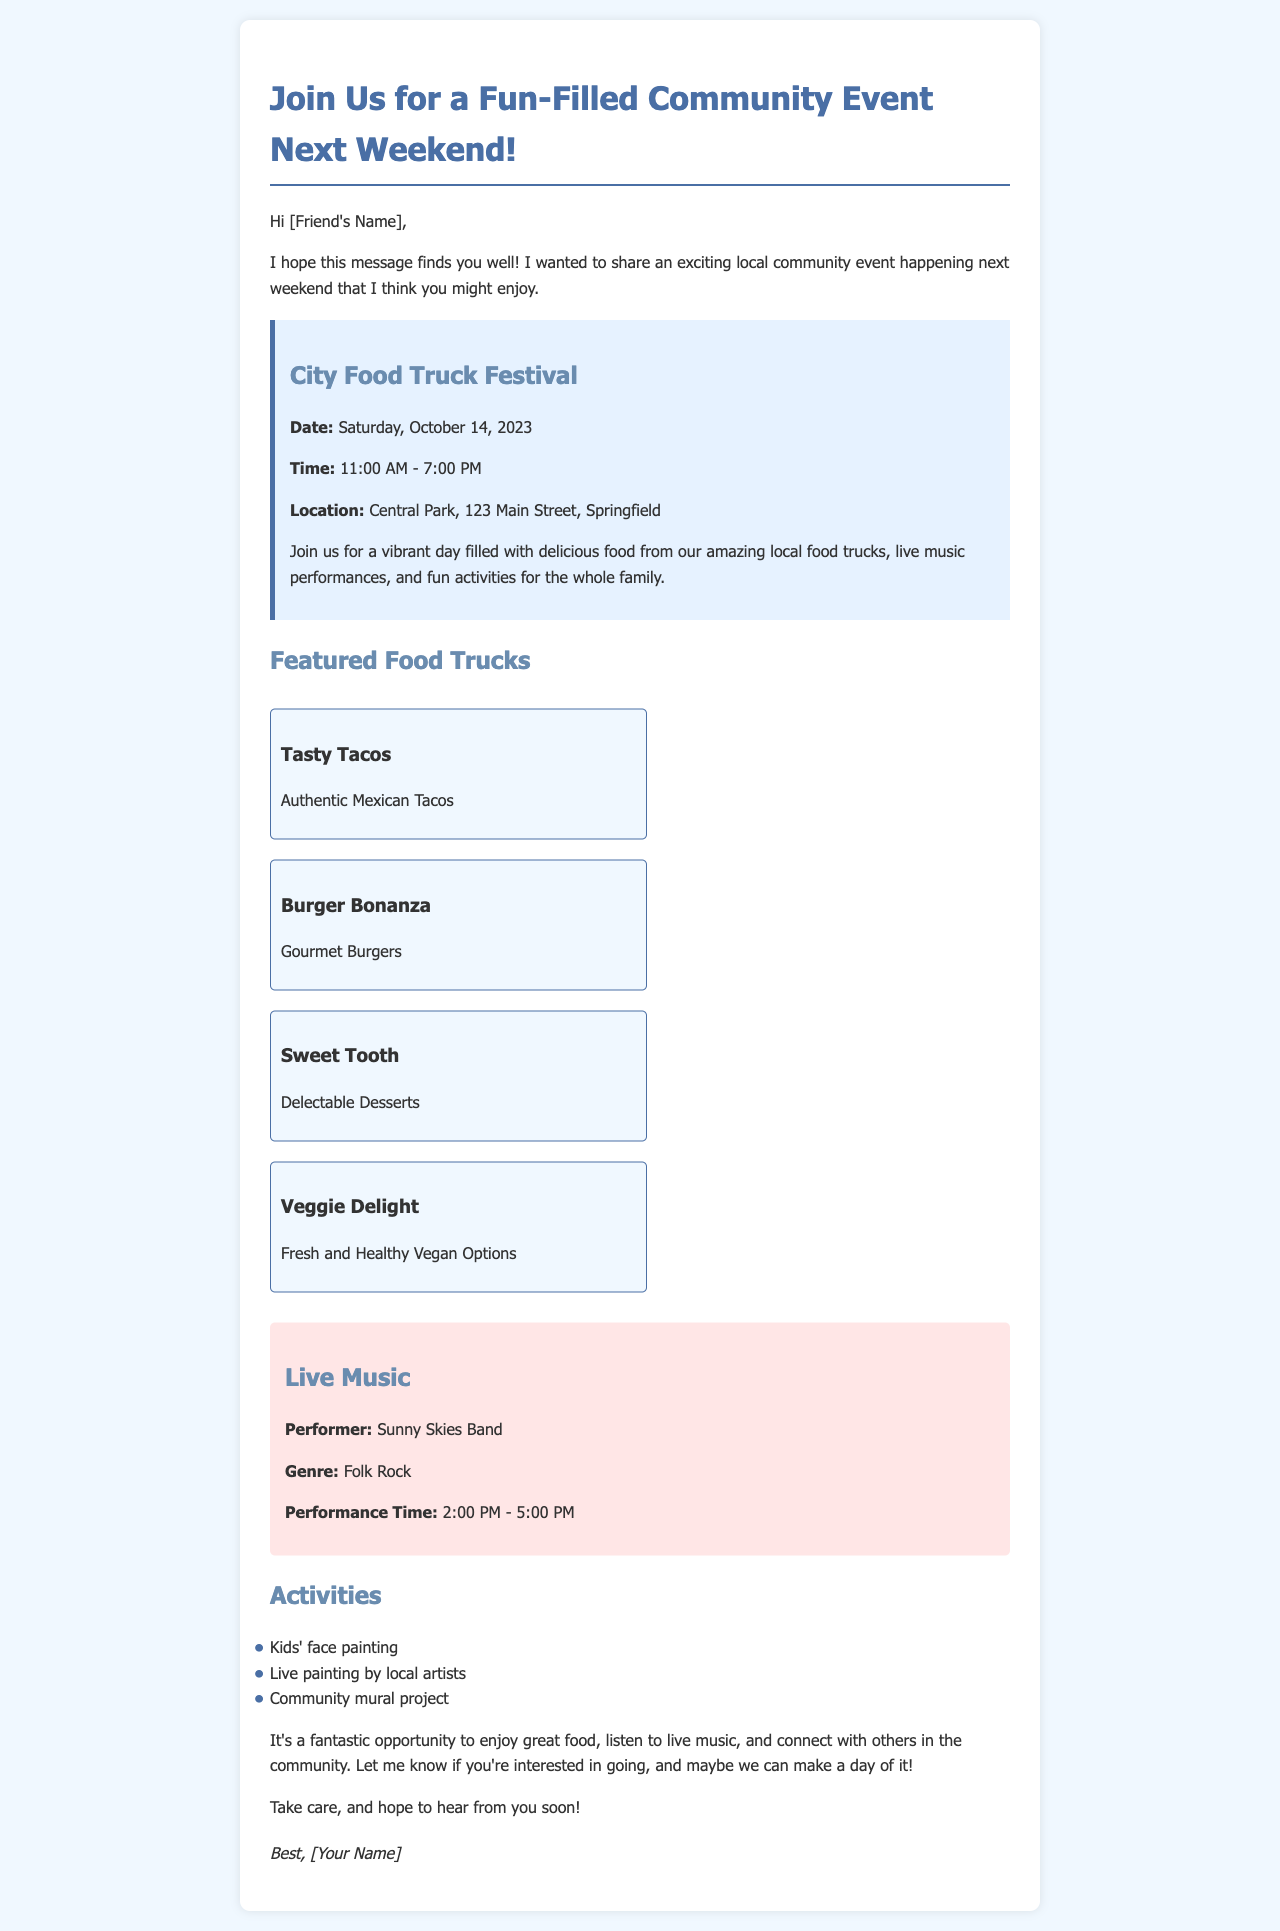What is the name of the event? The name of the event is specified in the document as "City Food Truck Festival".
Answer: City Food Truck Festival What is the date of the event? The document clearly states that the event is scheduled for "Saturday, October 14, 2023".
Answer: Saturday, October 14, 2023 What are the event's operating hours? The document provides the time frame for the event, which is "11:00 AM - 7:00 PM".
Answer: 11:00 AM - 7:00 PM Who is the performer at the event? The performer is identified in the music section of the document as "Sunny Skies Band".
Answer: Sunny Skies Band What type of music will be performed? The genre of music mentioned in the document is "Folk Rock".
Answer: Folk Rock How many food trucks are featured at the event? The document lists a total of four food trucks, which includes "Tasty Tacos", "Burger Bonanza", "Sweet Tooth", and "Veggie Delight".
Answer: Four What activities are available for children? The document mentions "Kids' face painting" as one of the activities for children at the event.
Answer: Kids' face painting What is the location of the event? The document specifies the event location as "Central Park, 123 Main Street, Springfield".
Answer: Central Park, 123 Main Street, Springfield What is the main purpose of the event? The purpose is highlighted as an opportunity to “enjoy great food, listen to live music, and connect with others in the community.”
Answer: Enjoy great food, listen to live music, and connect with others in the community 